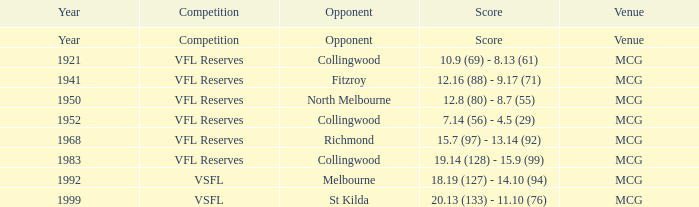At what venue was there a competition with a score reported as 7.14 (56) - 4.5 (29)? MCG. 